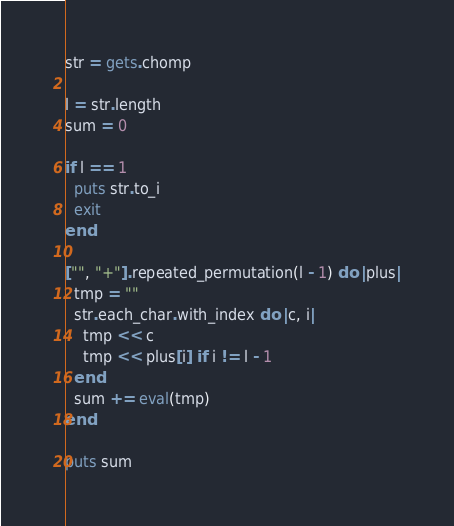Convert code to text. <code><loc_0><loc_0><loc_500><loc_500><_Ruby_>str = gets.chomp

l = str.length
sum = 0

if l == 1
  puts str.to_i
  exit
end

["", "+"].repeated_permutation(l - 1) do |plus|
  tmp = ""
  str.each_char.with_index do |c, i|
    tmp << c
    tmp << plus[i] if i != l - 1
  end
  sum += eval(tmp)
end

puts sum</code> 